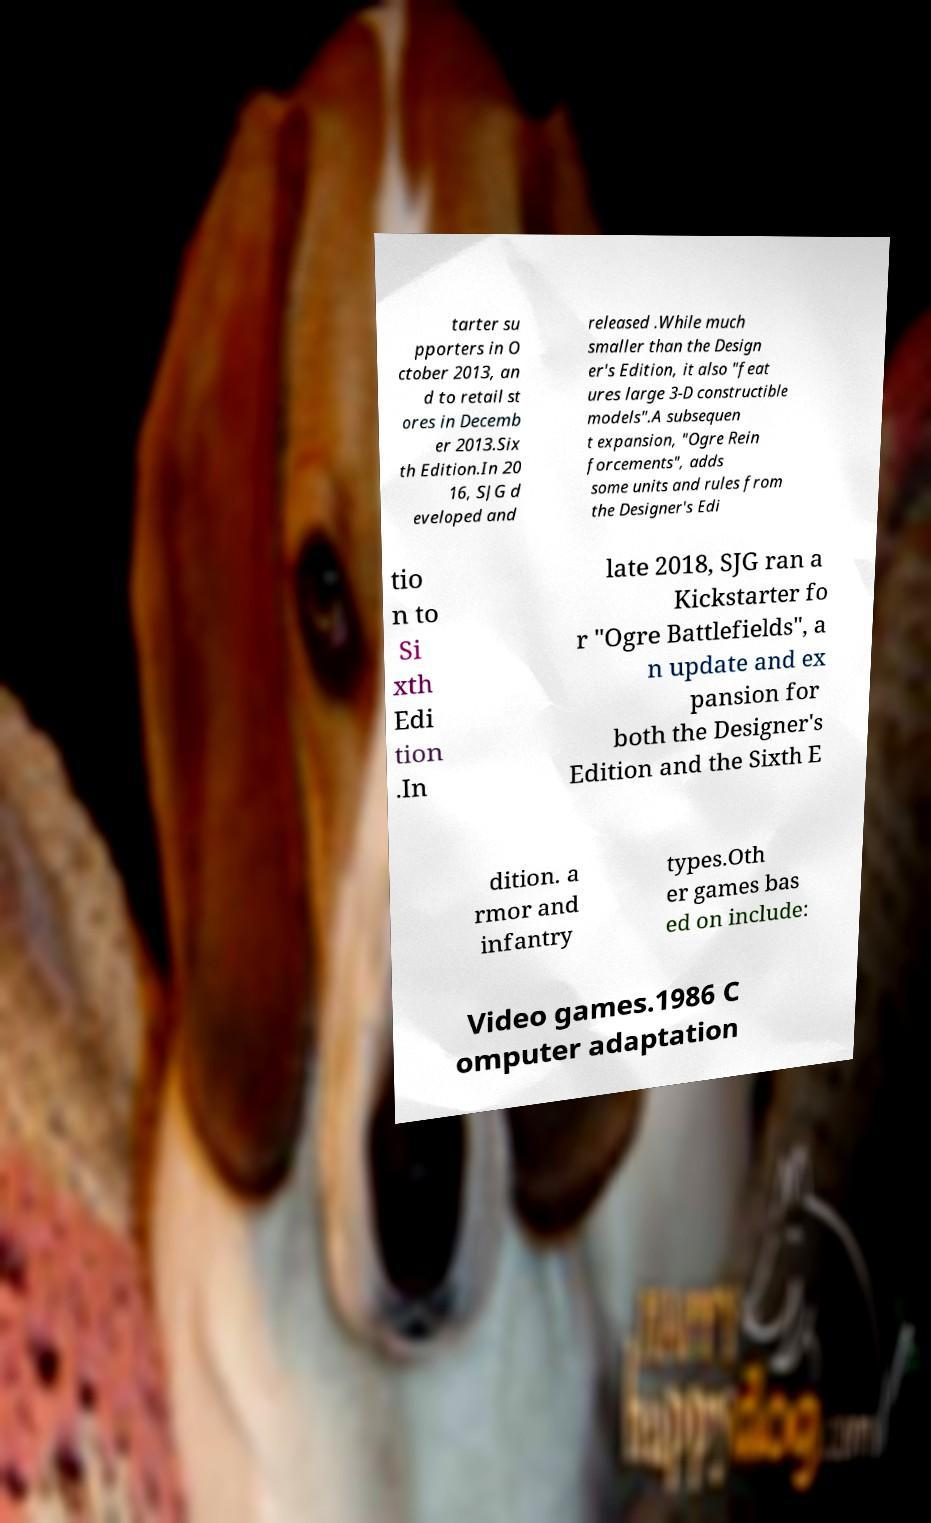Can you accurately transcribe the text from the provided image for me? tarter su pporters in O ctober 2013, an d to retail st ores in Decemb er 2013.Six th Edition.In 20 16, SJG d eveloped and released .While much smaller than the Design er's Edition, it also "feat ures large 3-D constructible models".A subsequen t expansion, "Ogre Rein forcements", adds some units and rules from the Designer's Edi tio n to Si xth Edi tion .In late 2018, SJG ran a Kickstarter fo r "Ogre Battlefields", a n update and ex pansion for both the Designer's Edition and the Sixth E dition. a rmor and infantry types.Oth er games bas ed on include: Video games.1986 C omputer adaptation 